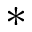Convert formula to latex. <formula><loc_0><loc_0><loc_500><loc_500>*</formula> 